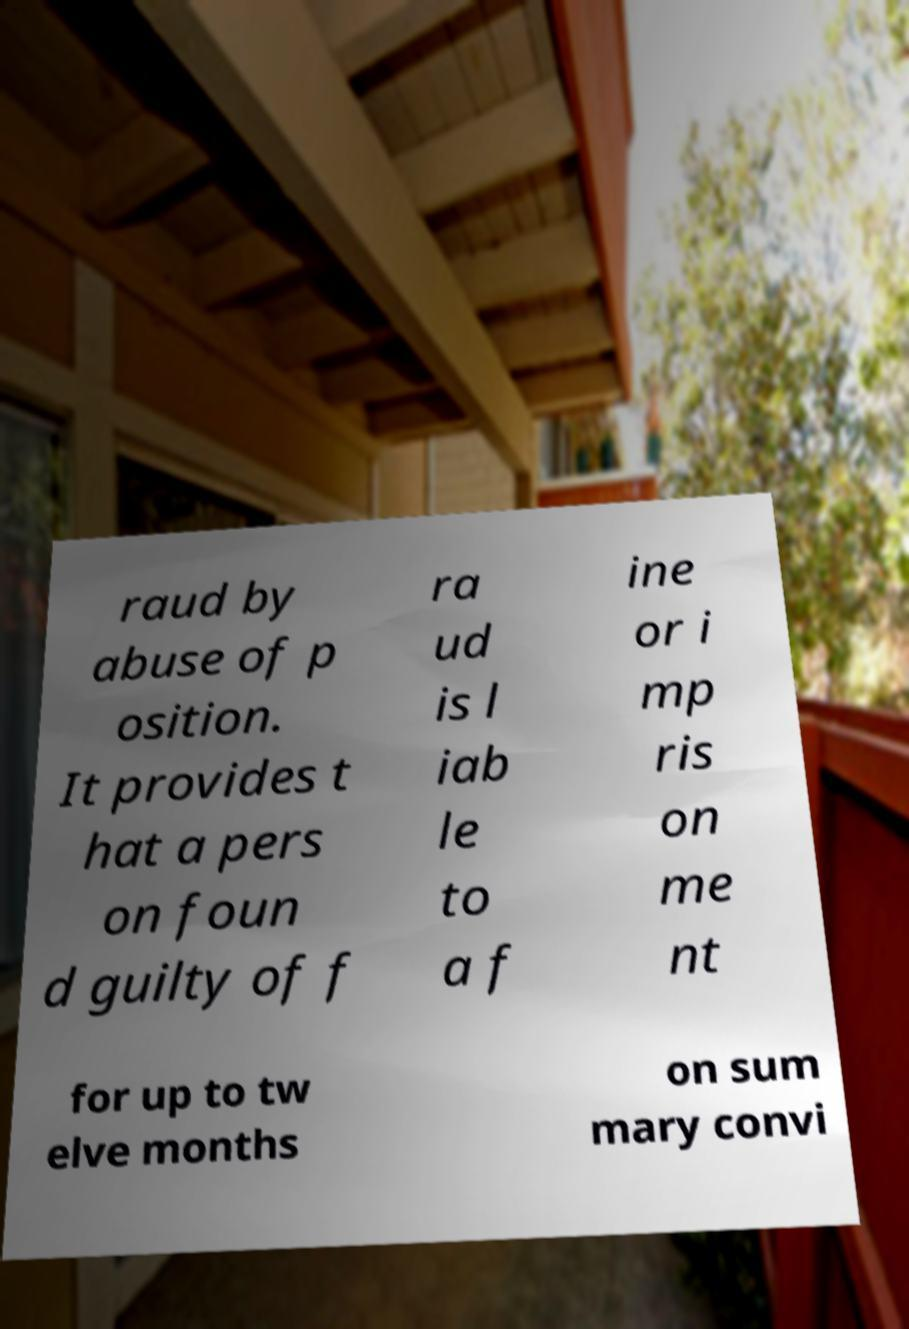There's text embedded in this image that I need extracted. Can you transcribe it verbatim? raud by abuse of p osition. It provides t hat a pers on foun d guilty of f ra ud is l iab le to a f ine or i mp ris on me nt for up to tw elve months on sum mary convi 